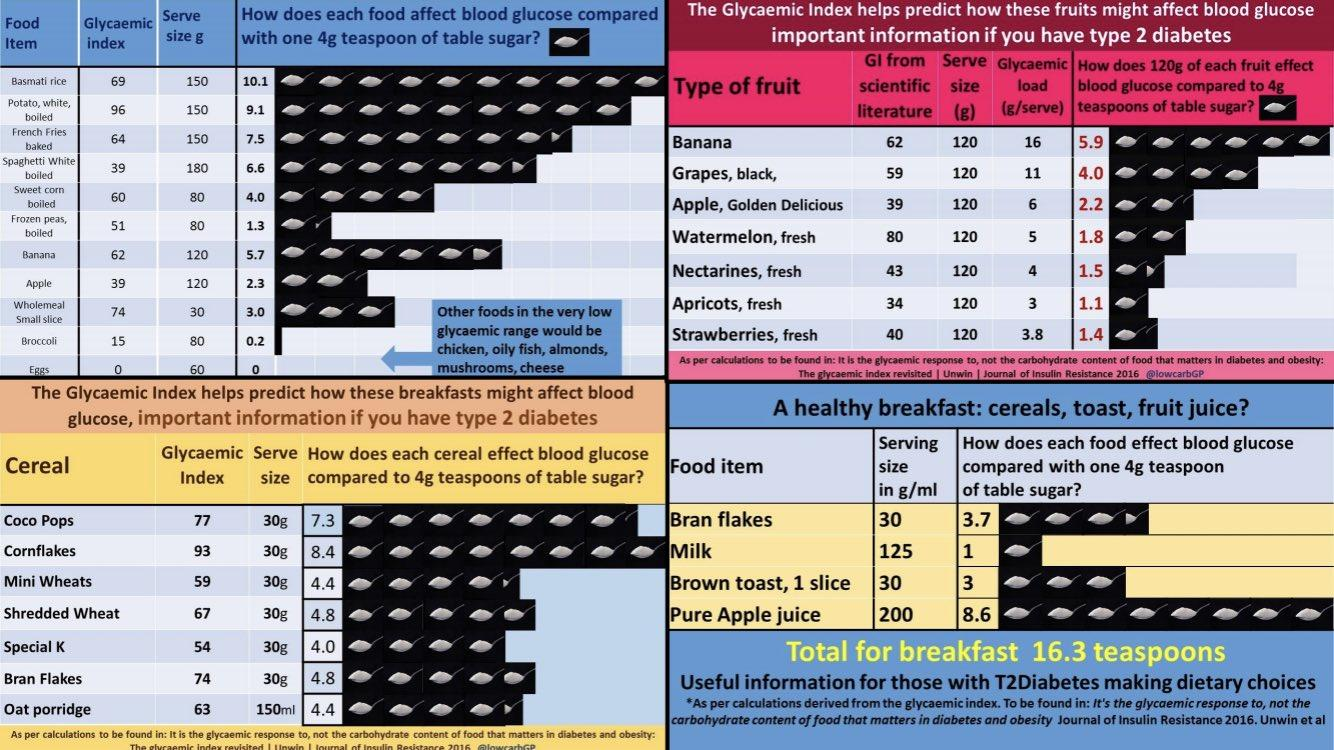Indicate a few pertinent items in this graphic. According to a glycemic index of 62 for a 120g serve size of banana, it is considered to have a moderate effect on blood sugar levels. The glycemic index of eggs is 1-2, with a 60g serve size. 